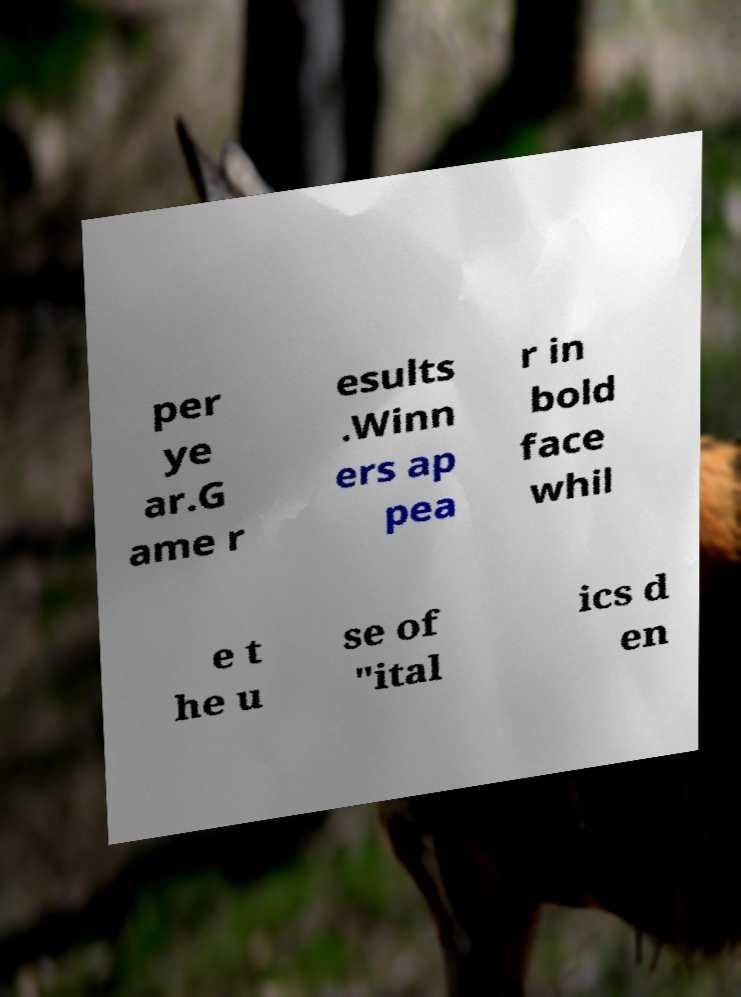Please identify and transcribe the text found in this image. per ye ar.G ame r esults .Winn ers ap pea r in bold face whil e t he u se of "ital ics d en 